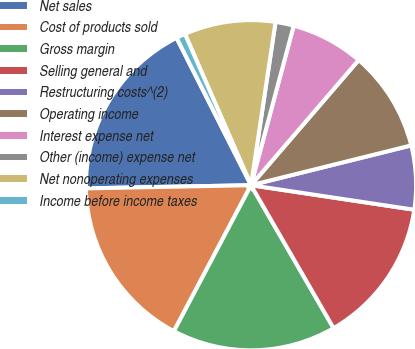Convert chart to OTSL. <chart><loc_0><loc_0><loc_500><loc_500><pie_chart><fcel>Net sales<fcel>Cost of products sold<fcel>Gross margin<fcel>Selling general and<fcel>Restructuring costs^(2)<fcel>Operating income<fcel>Interest expense net<fcel>Other (income) expense net<fcel>Net nonoperating expenses<fcel>Income before income taxes<nl><fcel>17.86%<fcel>16.96%<fcel>16.07%<fcel>14.29%<fcel>6.25%<fcel>9.82%<fcel>7.14%<fcel>1.79%<fcel>8.93%<fcel>0.89%<nl></chart> 